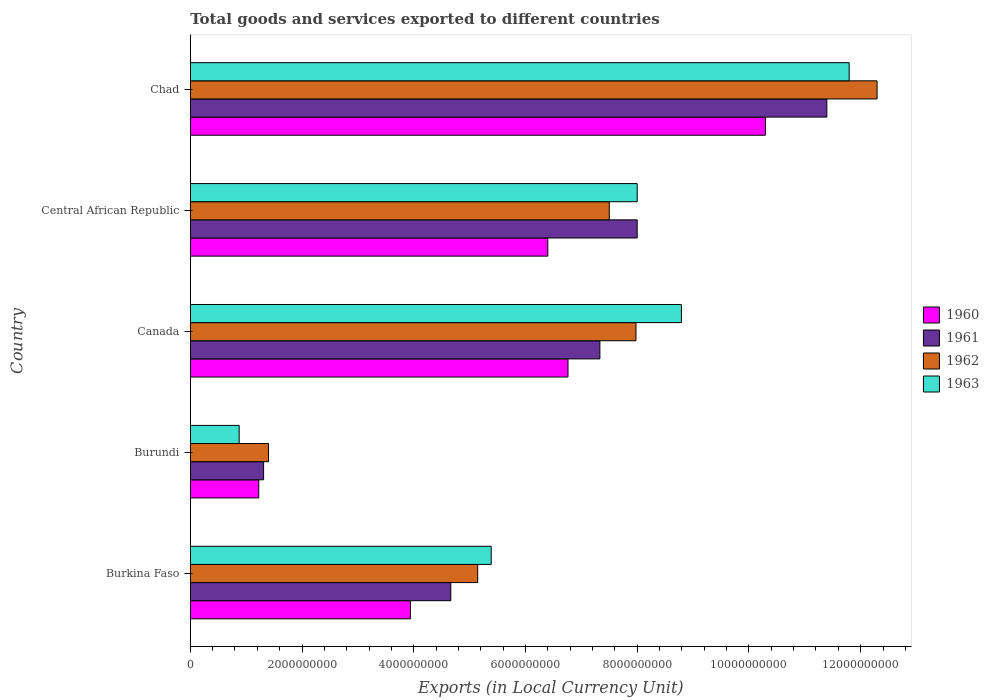How many different coloured bars are there?
Your response must be concise. 4. How many groups of bars are there?
Provide a succinct answer. 5. Are the number of bars on each tick of the Y-axis equal?
Make the answer very short. Yes. How many bars are there on the 1st tick from the top?
Your response must be concise. 4. What is the label of the 2nd group of bars from the top?
Ensure brevity in your answer.  Central African Republic. In how many cases, is the number of bars for a given country not equal to the number of legend labels?
Offer a terse response. 0. What is the Amount of goods and services exports in 1963 in Canada?
Your response must be concise. 8.79e+09. Across all countries, what is the maximum Amount of goods and services exports in 1961?
Provide a succinct answer. 1.14e+1. Across all countries, what is the minimum Amount of goods and services exports in 1961?
Give a very brief answer. 1.31e+09. In which country was the Amount of goods and services exports in 1963 maximum?
Your answer should be compact. Chad. In which country was the Amount of goods and services exports in 1960 minimum?
Offer a very short reply. Burundi. What is the total Amount of goods and services exports in 1963 in the graph?
Offer a terse response. 3.48e+1. What is the difference between the Amount of goods and services exports in 1961 in Central African Republic and that in Chad?
Offer a terse response. -3.39e+09. What is the difference between the Amount of goods and services exports in 1963 in Burundi and the Amount of goods and services exports in 1962 in Burkina Faso?
Give a very brief answer. -4.27e+09. What is the average Amount of goods and services exports in 1961 per country?
Ensure brevity in your answer.  6.54e+09. What is the difference between the Amount of goods and services exports in 1962 and Amount of goods and services exports in 1961 in Central African Republic?
Keep it short and to the point. -5.00e+08. What is the ratio of the Amount of goods and services exports in 1962 in Burkina Faso to that in Central African Republic?
Your answer should be very brief. 0.69. Is the difference between the Amount of goods and services exports in 1962 in Canada and Central African Republic greater than the difference between the Amount of goods and services exports in 1961 in Canada and Central African Republic?
Ensure brevity in your answer.  Yes. What is the difference between the highest and the second highest Amount of goods and services exports in 1960?
Offer a very short reply. 3.53e+09. What is the difference between the highest and the lowest Amount of goods and services exports in 1961?
Make the answer very short. 1.01e+1. Is the sum of the Amount of goods and services exports in 1961 in Central African Republic and Chad greater than the maximum Amount of goods and services exports in 1962 across all countries?
Your response must be concise. Yes. Is it the case that in every country, the sum of the Amount of goods and services exports in 1961 and Amount of goods and services exports in 1963 is greater than the sum of Amount of goods and services exports in 1960 and Amount of goods and services exports in 1962?
Offer a terse response. No. What does the 1st bar from the top in Burundi represents?
Make the answer very short. 1963. What does the 1st bar from the bottom in Burkina Faso represents?
Make the answer very short. 1960. How many bars are there?
Your answer should be compact. 20. What is the difference between two consecutive major ticks on the X-axis?
Keep it short and to the point. 2.00e+09. Does the graph contain any zero values?
Offer a very short reply. No. Does the graph contain grids?
Provide a short and direct response. No. How many legend labels are there?
Offer a terse response. 4. What is the title of the graph?
Your response must be concise. Total goods and services exported to different countries. Does "1968" appear as one of the legend labels in the graph?
Offer a very short reply. No. What is the label or title of the X-axis?
Keep it short and to the point. Exports (in Local Currency Unit). What is the Exports (in Local Currency Unit) in 1960 in Burkina Faso?
Ensure brevity in your answer.  3.94e+09. What is the Exports (in Local Currency Unit) of 1961 in Burkina Faso?
Your answer should be compact. 4.66e+09. What is the Exports (in Local Currency Unit) of 1962 in Burkina Faso?
Make the answer very short. 5.14e+09. What is the Exports (in Local Currency Unit) in 1963 in Burkina Faso?
Your answer should be very brief. 5.39e+09. What is the Exports (in Local Currency Unit) of 1960 in Burundi?
Your response must be concise. 1.22e+09. What is the Exports (in Local Currency Unit) in 1961 in Burundi?
Your response must be concise. 1.31e+09. What is the Exports (in Local Currency Unit) in 1962 in Burundi?
Provide a short and direct response. 1.40e+09. What is the Exports (in Local Currency Unit) in 1963 in Burundi?
Provide a short and direct response. 8.75e+08. What is the Exports (in Local Currency Unit) of 1960 in Canada?
Keep it short and to the point. 6.76e+09. What is the Exports (in Local Currency Unit) of 1961 in Canada?
Offer a terse response. 7.33e+09. What is the Exports (in Local Currency Unit) in 1962 in Canada?
Offer a terse response. 7.98e+09. What is the Exports (in Local Currency Unit) in 1963 in Canada?
Provide a short and direct response. 8.79e+09. What is the Exports (in Local Currency Unit) in 1960 in Central African Republic?
Offer a very short reply. 6.40e+09. What is the Exports (in Local Currency Unit) in 1961 in Central African Republic?
Provide a short and direct response. 8.00e+09. What is the Exports (in Local Currency Unit) in 1962 in Central African Republic?
Keep it short and to the point. 7.50e+09. What is the Exports (in Local Currency Unit) in 1963 in Central African Republic?
Provide a succinct answer. 8.00e+09. What is the Exports (in Local Currency Unit) in 1960 in Chad?
Your answer should be very brief. 1.03e+1. What is the Exports (in Local Currency Unit) of 1961 in Chad?
Your response must be concise. 1.14e+1. What is the Exports (in Local Currency Unit) of 1962 in Chad?
Offer a very short reply. 1.23e+1. What is the Exports (in Local Currency Unit) of 1963 in Chad?
Keep it short and to the point. 1.18e+1. Across all countries, what is the maximum Exports (in Local Currency Unit) in 1960?
Your answer should be very brief. 1.03e+1. Across all countries, what is the maximum Exports (in Local Currency Unit) in 1961?
Make the answer very short. 1.14e+1. Across all countries, what is the maximum Exports (in Local Currency Unit) in 1962?
Give a very brief answer. 1.23e+1. Across all countries, what is the maximum Exports (in Local Currency Unit) in 1963?
Keep it short and to the point. 1.18e+1. Across all countries, what is the minimum Exports (in Local Currency Unit) of 1960?
Your answer should be compact. 1.22e+09. Across all countries, what is the minimum Exports (in Local Currency Unit) of 1961?
Provide a succinct answer. 1.31e+09. Across all countries, what is the minimum Exports (in Local Currency Unit) in 1962?
Your response must be concise. 1.40e+09. Across all countries, what is the minimum Exports (in Local Currency Unit) of 1963?
Provide a short and direct response. 8.75e+08. What is the total Exports (in Local Currency Unit) in 1960 in the graph?
Provide a short and direct response. 2.86e+1. What is the total Exports (in Local Currency Unit) of 1961 in the graph?
Offer a terse response. 3.27e+1. What is the total Exports (in Local Currency Unit) of 1962 in the graph?
Offer a terse response. 3.43e+1. What is the total Exports (in Local Currency Unit) of 1963 in the graph?
Your response must be concise. 3.48e+1. What is the difference between the Exports (in Local Currency Unit) in 1960 in Burkina Faso and that in Burundi?
Offer a terse response. 2.71e+09. What is the difference between the Exports (in Local Currency Unit) in 1961 in Burkina Faso and that in Burundi?
Your response must be concise. 3.35e+09. What is the difference between the Exports (in Local Currency Unit) of 1962 in Burkina Faso and that in Burundi?
Offer a terse response. 3.74e+09. What is the difference between the Exports (in Local Currency Unit) in 1963 in Burkina Faso and that in Burundi?
Keep it short and to the point. 4.51e+09. What is the difference between the Exports (in Local Currency Unit) of 1960 in Burkina Faso and that in Canada?
Your answer should be very brief. -2.82e+09. What is the difference between the Exports (in Local Currency Unit) of 1961 in Burkina Faso and that in Canada?
Make the answer very short. -2.67e+09. What is the difference between the Exports (in Local Currency Unit) in 1962 in Burkina Faso and that in Canada?
Provide a succinct answer. -2.83e+09. What is the difference between the Exports (in Local Currency Unit) in 1963 in Burkina Faso and that in Canada?
Ensure brevity in your answer.  -3.40e+09. What is the difference between the Exports (in Local Currency Unit) of 1960 in Burkina Faso and that in Central African Republic?
Ensure brevity in your answer.  -2.46e+09. What is the difference between the Exports (in Local Currency Unit) in 1961 in Burkina Faso and that in Central African Republic?
Keep it short and to the point. -3.34e+09. What is the difference between the Exports (in Local Currency Unit) in 1962 in Burkina Faso and that in Central African Republic?
Make the answer very short. -2.36e+09. What is the difference between the Exports (in Local Currency Unit) of 1963 in Burkina Faso and that in Central African Republic?
Your answer should be very brief. -2.61e+09. What is the difference between the Exports (in Local Currency Unit) in 1960 in Burkina Faso and that in Chad?
Make the answer very short. -6.36e+09. What is the difference between the Exports (in Local Currency Unit) of 1961 in Burkina Faso and that in Chad?
Keep it short and to the point. -6.73e+09. What is the difference between the Exports (in Local Currency Unit) in 1962 in Burkina Faso and that in Chad?
Give a very brief answer. -7.15e+09. What is the difference between the Exports (in Local Currency Unit) of 1963 in Burkina Faso and that in Chad?
Provide a short and direct response. -6.41e+09. What is the difference between the Exports (in Local Currency Unit) in 1960 in Burundi and that in Canada?
Give a very brief answer. -5.54e+09. What is the difference between the Exports (in Local Currency Unit) in 1961 in Burundi and that in Canada?
Provide a short and direct response. -6.02e+09. What is the difference between the Exports (in Local Currency Unit) in 1962 in Burundi and that in Canada?
Ensure brevity in your answer.  -6.58e+09. What is the difference between the Exports (in Local Currency Unit) of 1963 in Burundi and that in Canada?
Give a very brief answer. -7.92e+09. What is the difference between the Exports (in Local Currency Unit) of 1960 in Burundi and that in Central African Republic?
Offer a very short reply. -5.18e+09. What is the difference between the Exports (in Local Currency Unit) in 1961 in Burundi and that in Central African Republic?
Give a very brief answer. -6.69e+09. What is the difference between the Exports (in Local Currency Unit) in 1962 in Burundi and that in Central African Republic?
Your answer should be very brief. -6.10e+09. What is the difference between the Exports (in Local Currency Unit) in 1963 in Burundi and that in Central African Republic?
Keep it short and to the point. -7.12e+09. What is the difference between the Exports (in Local Currency Unit) in 1960 in Burundi and that in Chad?
Your response must be concise. -9.07e+09. What is the difference between the Exports (in Local Currency Unit) of 1961 in Burundi and that in Chad?
Your response must be concise. -1.01e+1. What is the difference between the Exports (in Local Currency Unit) of 1962 in Burundi and that in Chad?
Your answer should be compact. -1.09e+1. What is the difference between the Exports (in Local Currency Unit) of 1963 in Burundi and that in Chad?
Your answer should be compact. -1.09e+1. What is the difference between the Exports (in Local Currency Unit) of 1960 in Canada and that in Central African Republic?
Your answer should be very brief. 3.61e+08. What is the difference between the Exports (in Local Currency Unit) of 1961 in Canada and that in Central African Republic?
Offer a terse response. -6.68e+08. What is the difference between the Exports (in Local Currency Unit) of 1962 in Canada and that in Central African Republic?
Your answer should be very brief. 4.78e+08. What is the difference between the Exports (in Local Currency Unit) in 1963 in Canada and that in Central African Republic?
Provide a succinct answer. 7.91e+08. What is the difference between the Exports (in Local Currency Unit) of 1960 in Canada and that in Chad?
Your answer should be very brief. -3.53e+09. What is the difference between the Exports (in Local Currency Unit) in 1961 in Canada and that in Chad?
Provide a short and direct response. -4.06e+09. What is the difference between the Exports (in Local Currency Unit) in 1962 in Canada and that in Chad?
Keep it short and to the point. -4.32e+09. What is the difference between the Exports (in Local Currency Unit) in 1963 in Canada and that in Chad?
Make the answer very short. -3.00e+09. What is the difference between the Exports (in Local Currency Unit) of 1960 in Central African Republic and that in Chad?
Ensure brevity in your answer.  -3.90e+09. What is the difference between the Exports (in Local Currency Unit) of 1961 in Central African Republic and that in Chad?
Your answer should be very brief. -3.39e+09. What is the difference between the Exports (in Local Currency Unit) in 1962 in Central African Republic and that in Chad?
Ensure brevity in your answer.  -4.79e+09. What is the difference between the Exports (in Local Currency Unit) in 1963 in Central African Republic and that in Chad?
Offer a very short reply. -3.79e+09. What is the difference between the Exports (in Local Currency Unit) in 1960 in Burkina Faso and the Exports (in Local Currency Unit) in 1961 in Burundi?
Your response must be concise. 2.63e+09. What is the difference between the Exports (in Local Currency Unit) of 1960 in Burkina Faso and the Exports (in Local Currency Unit) of 1962 in Burundi?
Provide a succinct answer. 2.54e+09. What is the difference between the Exports (in Local Currency Unit) in 1960 in Burkina Faso and the Exports (in Local Currency Unit) in 1963 in Burundi?
Provide a short and direct response. 3.06e+09. What is the difference between the Exports (in Local Currency Unit) in 1961 in Burkina Faso and the Exports (in Local Currency Unit) in 1962 in Burundi?
Keep it short and to the point. 3.26e+09. What is the difference between the Exports (in Local Currency Unit) in 1961 in Burkina Faso and the Exports (in Local Currency Unit) in 1963 in Burundi?
Your response must be concise. 3.79e+09. What is the difference between the Exports (in Local Currency Unit) of 1962 in Burkina Faso and the Exports (in Local Currency Unit) of 1963 in Burundi?
Your response must be concise. 4.27e+09. What is the difference between the Exports (in Local Currency Unit) in 1960 in Burkina Faso and the Exports (in Local Currency Unit) in 1961 in Canada?
Your response must be concise. -3.39e+09. What is the difference between the Exports (in Local Currency Unit) in 1960 in Burkina Faso and the Exports (in Local Currency Unit) in 1962 in Canada?
Your response must be concise. -4.04e+09. What is the difference between the Exports (in Local Currency Unit) in 1960 in Burkina Faso and the Exports (in Local Currency Unit) in 1963 in Canada?
Your answer should be very brief. -4.85e+09. What is the difference between the Exports (in Local Currency Unit) in 1961 in Burkina Faso and the Exports (in Local Currency Unit) in 1962 in Canada?
Keep it short and to the point. -3.31e+09. What is the difference between the Exports (in Local Currency Unit) in 1961 in Burkina Faso and the Exports (in Local Currency Unit) in 1963 in Canada?
Offer a very short reply. -4.13e+09. What is the difference between the Exports (in Local Currency Unit) in 1962 in Burkina Faso and the Exports (in Local Currency Unit) in 1963 in Canada?
Give a very brief answer. -3.65e+09. What is the difference between the Exports (in Local Currency Unit) of 1960 in Burkina Faso and the Exports (in Local Currency Unit) of 1961 in Central African Republic?
Your answer should be very brief. -4.06e+09. What is the difference between the Exports (in Local Currency Unit) in 1960 in Burkina Faso and the Exports (in Local Currency Unit) in 1962 in Central African Republic?
Ensure brevity in your answer.  -3.56e+09. What is the difference between the Exports (in Local Currency Unit) in 1960 in Burkina Faso and the Exports (in Local Currency Unit) in 1963 in Central African Republic?
Make the answer very short. -4.06e+09. What is the difference between the Exports (in Local Currency Unit) of 1961 in Burkina Faso and the Exports (in Local Currency Unit) of 1962 in Central African Republic?
Give a very brief answer. -2.84e+09. What is the difference between the Exports (in Local Currency Unit) of 1961 in Burkina Faso and the Exports (in Local Currency Unit) of 1963 in Central African Republic?
Your response must be concise. -3.34e+09. What is the difference between the Exports (in Local Currency Unit) of 1962 in Burkina Faso and the Exports (in Local Currency Unit) of 1963 in Central African Republic?
Offer a very short reply. -2.86e+09. What is the difference between the Exports (in Local Currency Unit) in 1960 in Burkina Faso and the Exports (in Local Currency Unit) in 1961 in Chad?
Provide a succinct answer. -7.46e+09. What is the difference between the Exports (in Local Currency Unit) in 1960 in Burkina Faso and the Exports (in Local Currency Unit) in 1962 in Chad?
Offer a terse response. -8.35e+09. What is the difference between the Exports (in Local Currency Unit) of 1960 in Burkina Faso and the Exports (in Local Currency Unit) of 1963 in Chad?
Your answer should be compact. -7.86e+09. What is the difference between the Exports (in Local Currency Unit) in 1961 in Burkina Faso and the Exports (in Local Currency Unit) in 1962 in Chad?
Provide a short and direct response. -7.63e+09. What is the difference between the Exports (in Local Currency Unit) of 1961 in Burkina Faso and the Exports (in Local Currency Unit) of 1963 in Chad?
Offer a very short reply. -7.13e+09. What is the difference between the Exports (in Local Currency Unit) of 1962 in Burkina Faso and the Exports (in Local Currency Unit) of 1963 in Chad?
Your answer should be very brief. -6.65e+09. What is the difference between the Exports (in Local Currency Unit) in 1960 in Burundi and the Exports (in Local Currency Unit) in 1961 in Canada?
Offer a terse response. -6.11e+09. What is the difference between the Exports (in Local Currency Unit) of 1960 in Burundi and the Exports (in Local Currency Unit) of 1962 in Canada?
Your answer should be compact. -6.75e+09. What is the difference between the Exports (in Local Currency Unit) in 1960 in Burundi and the Exports (in Local Currency Unit) in 1963 in Canada?
Make the answer very short. -7.57e+09. What is the difference between the Exports (in Local Currency Unit) in 1961 in Burundi and the Exports (in Local Currency Unit) in 1962 in Canada?
Ensure brevity in your answer.  -6.67e+09. What is the difference between the Exports (in Local Currency Unit) in 1961 in Burundi and the Exports (in Local Currency Unit) in 1963 in Canada?
Offer a terse response. -7.48e+09. What is the difference between the Exports (in Local Currency Unit) of 1962 in Burundi and the Exports (in Local Currency Unit) of 1963 in Canada?
Keep it short and to the point. -7.39e+09. What is the difference between the Exports (in Local Currency Unit) in 1960 in Burundi and the Exports (in Local Currency Unit) in 1961 in Central African Republic?
Keep it short and to the point. -6.78e+09. What is the difference between the Exports (in Local Currency Unit) in 1960 in Burundi and the Exports (in Local Currency Unit) in 1962 in Central African Republic?
Your answer should be compact. -6.28e+09. What is the difference between the Exports (in Local Currency Unit) of 1960 in Burundi and the Exports (in Local Currency Unit) of 1963 in Central African Republic?
Make the answer very short. -6.78e+09. What is the difference between the Exports (in Local Currency Unit) of 1961 in Burundi and the Exports (in Local Currency Unit) of 1962 in Central African Republic?
Keep it short and to the point. -6.19e+09. What is the difference between the Exports (in Local Currency Unit) in 1961 in Burundi and the Exports (in Local Currency Unit) in 1963 in Central African Republic?
Your response must be concise. -6.69e+09. What is the difference between the Exports (in Local Currency Unit) in 1962 in Burundi and the Exports (in Local Currency Unit) in 1963 in Central African Republic?
Your answer should be compact. -6.60e+09. What is the difference between the Exports (in Local Currency Unit) of 1960 in Burundi and the Exports (in Local Currency Unit) of 1961 in Chad?
Give a very brief answer. -1.02e+1. What is the difference between the Exports (in Local Currency Unit) in 1960 in Burundi and the Exports (in Local Currency Unit) in 1962 in Chad?
Offer a very short reply. -1.11e+1. What is the difference between the Exports (in Local Currency Unit) in 1960 in Burundi and the Exports (in Local Currency Unit) in 1963 in Chad?
Ensure brevity in your answer.  -1.06e+1. What is the difference between the Exports (in Local Currency Unit) in 1961 in Burundi and the Exports (in Local Currency Unit) in 1962 in Chad?
Keep it short and to the point. -1.10e+1. What is the difference between the Exports (in Local Currency Unit) in 1961 in Burundi and the Exports (in Local Currency Unit) in 1963 in Chad?
Give a very brief answer. -1.05e+1. What is the difference between the Exports (in Local Currency Unit) of 1962 in Burundi and the Exports (in Local Currency Unit) of 1963 in Chad?
Offer a terse response. -1.04e+1. What is the difference between the Exports (in Local Currency Unit) of 1960 in Canada and the Exports (in Local Currency Unit) of 1961 in Central African Republic?
Offer a terse response. -1.24e+09. What is the difference between the Exports (in Local Currency Unit) in 1960 in Canada and the Exports (in Local Currency Unit) in 1962 in Central African Republic?
Make the answer very short. -7.39e+08. What is the difference between the Exports (in Local Currency Unit) of 1960 in Canada and the Exports (in Local Currency Unit) of 1963 in Central African Republic?
Provide a short and direct response. -1.24e+09. What is the difference between the Exports (in Local Currency Unit) in 1961 in Canada and the Exports (in Local Currency Unit) in 1962 in Central African Republic?
Give a very brief answer. -1.68e+08. What is the difference between the Exports (in Local Currency Unit) of 1961 in Canada and the Exports (in Local Currency Unit) of 1963 in Central African Republic?
Provide a short and direct response. -6.68e+08. What is the difference between the Exports (in Local Currency Unit) in 1962 in Canada and the Exports (in Local Currency Unit) in 1963 in Central African Republic?
Your answer should be compact. -2.17e+07. What is the difference between the Exports (in Local Currency Unit) in 1960 in Canada and the Exports (in Local Currency Unit) in 1961 in Chad?
Your answer should be very brief. -4.63e+09. What is the difference between the Exports (in Local Currency Unit) in 1960 in Canada and the Exports (in Local Currency Unit) in 1962 in Chad?
Provide a succinct answer. -5.53e+09. What is the difference between the Exports (in Local Currency Unit) of 1960 in Canada and the Exports (in Local Currency Unit) of 1963 in Chad?
Provide a succinct answer. -5.03e+09. What is the difference between the Exports (in Local Currency Unit) of 1961 in Canada and the Exports (in Local Currency Unit) of 1962 in Chad?
Ensure brevity in your answer.  -4.96e+09. What is the difference between the Exports (in Local Currency Unit) in 1961 in Canada and the Exports (in Local Currency Unit) in 1963 in Chad?
Offer a very short reply. -4.46e+09. What is the difference between the Exports (in Local Currency Unit) in 1962 in Canada and the Exports (in Local Currency Unit) in 1963 in Chad?
Provide a short and direct response. -3.82e+09. What is the difference between the Exports (in Local Currency Unit) in 1960 in Central African Republic and the Exports (in Local Currency Unit) in 1961 in Chad?
Your answer should be compact. -4.99e+09. What is the difference between the Exports (in Local Currency Unit) in 1960 in Central African Republic and the Exports (in Local Currency Unit) in 1962 in Chad?
Make the answer very short. -5.89e+09. What is the difference between the Exports (in Local Currency Unit) of 1960 in Central African Republic and the Exports (in Local Currency Unit) of 1963 in Chad?
Make the answer very short. -5.39e+09. What is the difference between the Exports (in Local Currency Unit) in 1961 in Central African Republic and the Exports (in Local Currency Unit) in 1962 in Chad?
Ensure brevity in your answer.  -4.29e+09. What is the difference between the Exports (in Local Currency Unit) of 1961 in Central African Republic and the Exports (in Local Currency Unit) of 1963 in Chad?
Your answer should be compact. -3.79e+09. What is the difference between the Exports (in Local Currency Unit) in 1962 in Central African Republic and the Exports (in Local Currency Unit) in 1963 in Chad?
Your response must be concise. -4.29e+09. What is the average Exports (in Local Currency Unit) of 1960 per country?
Provide a short and direct response. 5.72e+09. What is the average Exports (in Local Currency Unit) of 1961 per country?
Make the answer very short. 6.54e+09. What is the average Exports (in Local Currency Unit) in 1962 per country?
Give a very brief answer. 6.86e+09. What is the average Exports (in Local Currency Unit) in 1963 per country?
Offer a very short reply. 6.97e+09. What is the difference between the Exports (in Local Currency Unit) of 1960 and Exports (in Local Currency Unit) of 1961 in Burkina Faso?
Give a very brief answer. -7.24e+08. What is the difference between the Exports (in Local Currency Unit) of 1960 and Exports (in Local Currency Unit) of 1962 in Burkina Faso?
Ensure brevity in your answer.  -1.21e+09. What is the difference between the Exports (in Local Currency Unit) in 1960 and Exports (in Local Currency Unit) in 1963 in Burkina Faso?
Give a very brief answer. -1.45e+09. What is the difference between the Exports (in Local Currency Unit) in 1961 and Exports (in Local Currency Unit) in 1962 in Burkina Faso?
Offer a very short reply. -4.81e+08. What is the difference between the Exports (in Local Currency Unit) in 1961 and Exports (in Local Currency Unit) in 1963 in Burkina Faso?
Make the answer very short. -7.23e+08. What is the difference between the Exports (in Local Currency Unit) of 1962 and Exports (in Local Currency Unit) of 1963 in Burkina Faso?
Make the answer very short. -2.42e+08. What is the difference between the Exports (in Local Currency Unit) of 1960 and Exports (in Local Currency Unit) of 1961 in Burundi?
Your answer should be compact. -8.75e+07. What is the difference between the Exports (in Local Currency Unit) of 1960 and Exports (in Local Currency Unit) of 1962 in Burundi?
Give a very brief answer. -1.75e+08. What is the difference between the Exports (in Local Currency Unit) of 1960 and Exports (in Local Currency Unit) of 1963 in Burundi?
Your answer should be compact. 3.50e+08. What is the difference between the Exports (in Local Currency Unit) of 1961 and Exports (in Local Currency Unit) of 1962 in Burundi?
Offer a terse response. -8.75e+07. What is the difference between the Exports (in Local Currency Unit) in 1961 and Exports (in Local Currency Unit) in 1963 in Burundi?
Make the answer very short. 4.38e+08. What is the difference between the Exports (in Local Currency Unit) of 1962 and Exports (in Local Currency Unit) of 1963 in Burundi?
Make the answer very short. 5.25e+08. What is the difference between the Exports (in Local Currency Unit) in 1960 and Exports (in Local Currency Unit) in 1961 in Canada?
Give a very brief answer. -5.71e+08. What is the difference between the Exports (in Local Currency Unit) in 1960 and Exports (in Local Currency Unit) in 1962 in Canada?
Your response must be concise. -1.22e+09. What is the difference between the Exports (in Local Currency Unit) of 1960 and Exports (in Local Currency Unit) of 1963 in Canada?
Your response must be concise. -2.03e+09. What is the difference between the Exports (in Local Currency Unit) of 1961 and Exports (in Local Currency Unit) of 1962 in Canada?
Make the answer very short. -6.46e+08. What is the difference between the Exports (in Local Currency Unit) of 1961 and Exports (in Local Currency Unit) of 1963 in Canada?
Give a very brief answer. -1.46e+09. What is the difference between the Exports (in Local Currency Unit) of 1962 and Exports (in Local Currency Unit) of 1963 in Canada?
Ensure brevity in your answer.  -8.13e+08. What is the difference between the Exports (in Local Currency Unit) of 1960 and Exports (in Local Currency Unit) of 1961 in Central African Republic?
Offer a very short reply. -1.60e+09. What is the difference between the Exports (in Local Currency Unit) in 1960 and Exports (in Local Currency Unit) in 1962 in Central African Republic?
Ensure brevity in your answer.  -1.10e+09. What is the difference between the Exports (in Local Currency Unit) of 1960 and Exports (in Local Currency Unit) of 1963 in Central African Republic?
Keep it short and to the point. -1.60e+09. What is the difference between the Exports (in Local Currency Unit) in 1961 and Exports (in Local Currency Unit) in 1962 in Central African Republic?
Provide a succinct answer. 5.00e+08. What is the difference between the Exports (in Local Currency Unit) of 1962 and Exports (in Local Currency Unit) of 1963 in Central African Republic?
Keep it short and to the point. -5.00e+08. What is the difference between the Exports (in Local Currency Unit) of 1960 and Exports (in Local Currency Unit) of 1961 in Chad?
Offer a terse response. -1.10e+09. What is the difference between the Exports (in Local Currency Unit) in 1960 and Exports (in Local Currency Unit) in 1962 in Chad?
Provide a short and direct response. -2.00e+09. What is the difference between the Exports (in Local Currency Unit) in 1960 and Exports (in Local Currency Unit) in 1963 in Chad?
Offer a terse response. -1.50e+09. What is the difference between the Exports (in Local Currency Unit) of 1961 and Exports (in Local Currency Unit) of 1962 in Chad?
Keep it short and to the point. -9.00e+08. What is the difference between the Exports (in Local Currency Unit) of 1961 and Exports (in Local Currency Unit) of 1963 in Chad?
Offer a very short reply. -4.00e+08. What is the difference between the Exports (in Local Currency Unit) of 1962 and Exports (in Local Currency Unit) of 1963 in Chad?
Ensure brevity in your answer.  5.00e+08. What is the ratio of the Exports (in Local Currency Unit) in 1960 in Burkina Faso to that in Burundi?
Give a very brief answer. 3.22. What is the ratio of the Exports (in Local Currency Unit) in 1961 in Burkina Faso to that in Burundi?
Give a very brief answer. 3.55. What is the ratio of the Exports (in Local Currency Unit) of 1962 in Burkina Faso to that in Burundi?
Give a very brief answer. 3.67. What is the ratio of the Exports (in Local Currency Unit) in 1963 in Burkina Faso to that in Burundi?
Your response must be concise. 6.16. What is the ratio of the Exports (in Local Currency Unit) of 1960 in Burkina Faso to that in Canada?
Ensure brevity in your answer.  0.58. What is the ratio of the Exports (in Local Currency Unit) in 1961 in Burkina Faso to that in Canada?
Offer a terse response. 0.64. What is the ratio of the Exports (in Local Currency Unit) of 1962 in Burkina Faso to that in Canada?
Keep it short and to the point. 0.64. What is the ratio of the Exports (in Local Currency Unit) of 1963 in Burkina Faso to that in Canada?
Provide a succinct answer. 0.61. What is the ratio of the Exports (in Local Currency Unit) of 1960 in Burkina Faso to that in Central African Republic?
Provide a short and direct response. 0.62. What is the ratio of the Exports (in Local Currency Unit) in 1961 in Burkina Faso to that in Central African Republic?
Provide a succinct answer. 0.58. What is the ratio of the Exports (in Local Currency Unit) of 1962 in Burkina Faso to that in Central African Republic?
Offer a terse response. 0.69. What is the ratio of the Exports (in Local Currency Unit) in 1963 in Burkina Faso to that in Central African Republic?
Your response must be concise. 0.67. What is the ratio of the Exports (in Local Currency Unit) in 1960 in Burkina Faso to that in Chad?
Your response must be concise. 0.38. What is the ratio of the Exports (in Local Currency Unit) in 1961 in Burkina Faso to that in Chad?
Provide a succinct answer. 0.41. What is the ratio of the Exports (in Local Currency Unit) of 1962 in Burkina Faso to that in Chad?
Your answer should be compact. 0.42. What is the ratio of the Exports (in Local Currency Unit) in 1963 in Burkina Faso to that in Chad?
Offer a very short reply. 0.46. What is the ratio of the Exports (in Local Currency Unit) of 1960 in Burundi to that in Canada?
Your answer should be compact. 0.18. What is the ratio of the Exports (in Local Currency Unit) of 1961 in Burundi to that in Canada?
Ensure brevity in your answer.  0.18. What is the ratio of the Exports (in Local Currency Unit) in 1962 in Burundi to that in Canada?
Your answer should be compact. 0.18. What is the ratio of the Exports (in Local Currency Unit) in 1963 in Burundi to that in Canada?
Offer a very short reply. 0.1. What is the ratio of the Exports (in Local Currency Unit) of 1960 in Burundi to that in Central African Republic?
Make the answer very short. 0.19. What is the ratio of the Exports (in Local Currency Unit) of 1961 in Burundi to that in Central African Republic?
Your response must be concise. 0.16. What is the ratio of the Exports (in Local Currency Unit) in 1962 in Burundi to that in Central African Republic?
Keep it short and to the point. 0.19. What is the ratio of the Exports (in Local Currency Unit) in 1963 in Burundi to that in Central African Republic?
Make the answer very short. 0.11. What is the ratio of the Exports (in Local Currency Unit) in 1960 in Burundi to that in Chad?
Your response must be concise. 0.12. What is the ratio of the Exports (in Local Currency Unit) in 1961 in Burundi to that in Chad?
Offer a terse response. 0.12. What is the ratio of the Exports (in Local Currency Unit) of 1962 in Burundi to that in Chad?
Your answer should be very brief. 0.11. What is the ratio of the Exports (in Local Currency Unit) in 1963 in Burundi to that in Chad?
Provide a short and direct response. 0.07. What is the ratio of the Exports (in Local Currency Unit) in 1960 in Canada to that in Central African Republic?
Provide a succinct answer. 1.06. What is the ratio of the Exports (in Local Currency Unit) in 1961 in Canada to that in Central African Republic?
Give a very brief answer. 0.92. What is the ratio of the Exports (in Local Currency Unit) in 1962 in Canada to that in Central African Republic?
Your answer should be compact. 1.06. What is the ratio of the Exports (in Local Currency Unit) of 1963 in Canada to that in Central African Republic?
Offer a terse response. 1.1. What is the ratio of the Exports (in Local Currency Unit) of 1960 in Canada to that in Chad?
Your answer should be very brief. 0.66. What is the ratio of the Exports (in Local Currency Unit) of 1961 in Canada to that in Chad?
Provide a succinct answer. 0.64. What is the ratio of the Exports (in Local Currency Unit) of 1962 in Canada to that in Chad?
Provide a succinct answer. 0.65. What is the ratio of the Exports (in Local Currency Unit) in 1963 in Canada to that in Chad?
Offer a very short reply. 0.75. What is the ratio of the Exports (in Local Currency Unit) in 1960 in Central African Republic to that in Chad?
Give a very brief answer. 0.62. What is the ratio of the Exports (in Local Currency Unit) of 1961 in Central African Republic to that in Chad?
Offer a very short reply. 0.7. What is the ratio of the Exports (in Local Currency Unit) in 1962 in Central African Republic to that in Chad?
Ensure brevity in your answer.  0.61. What is the ratio of the Exports (in Local Currency Unit) in 1963 in Central African Republic to that in Chad?
Keep it short and to the point. 0.68. What is the difference between the highest and the second highest Exports (in Local Currency Unit) in 1960?
Give a very brief answer. 3.53e+09. What is the difference between the highest and the second highest Exports (in Local Currency Unit) of 1961?
Ensure brevity in your answer.  3.39e+09. What is the difference between the highest and the second highest Exports (in Local Currency Unit) of 1962?
Provide a succinct answer. 4.32e+09. What is the difference between the highest and the second highest Exports (in Local Currency Unit) of 1963?
Your response must be concise. 3.00e+09. What is the difference between the highest and the lowest Exports (in Local Currency Unit) of 1960?
Make the answer very short. 9.07e+09. What is the difference between the highest and the lowest Exports (in Local Currency Unit) of 1961?
Offer a terse response. 1.01e+1. What is the difference between the highest and the lowest Exports (in Local Currency Unit) in 1962?
Your response must be concise. 1.09e+1. What is the difference between the highest and the lowest Exports (in Local Currency Unit) in 1963?
Your response must be concise. 1.09e+1. 